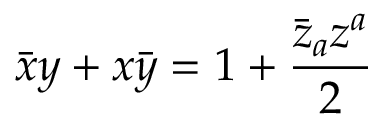Convert formula to latex. <formula><loc_0><loc_0><loc_500><loc_500>\bar { x } y + x \bar { y } = 1 + \frac { \bar { z } _ { a } z ^ { a } } { 2 }</formula> 